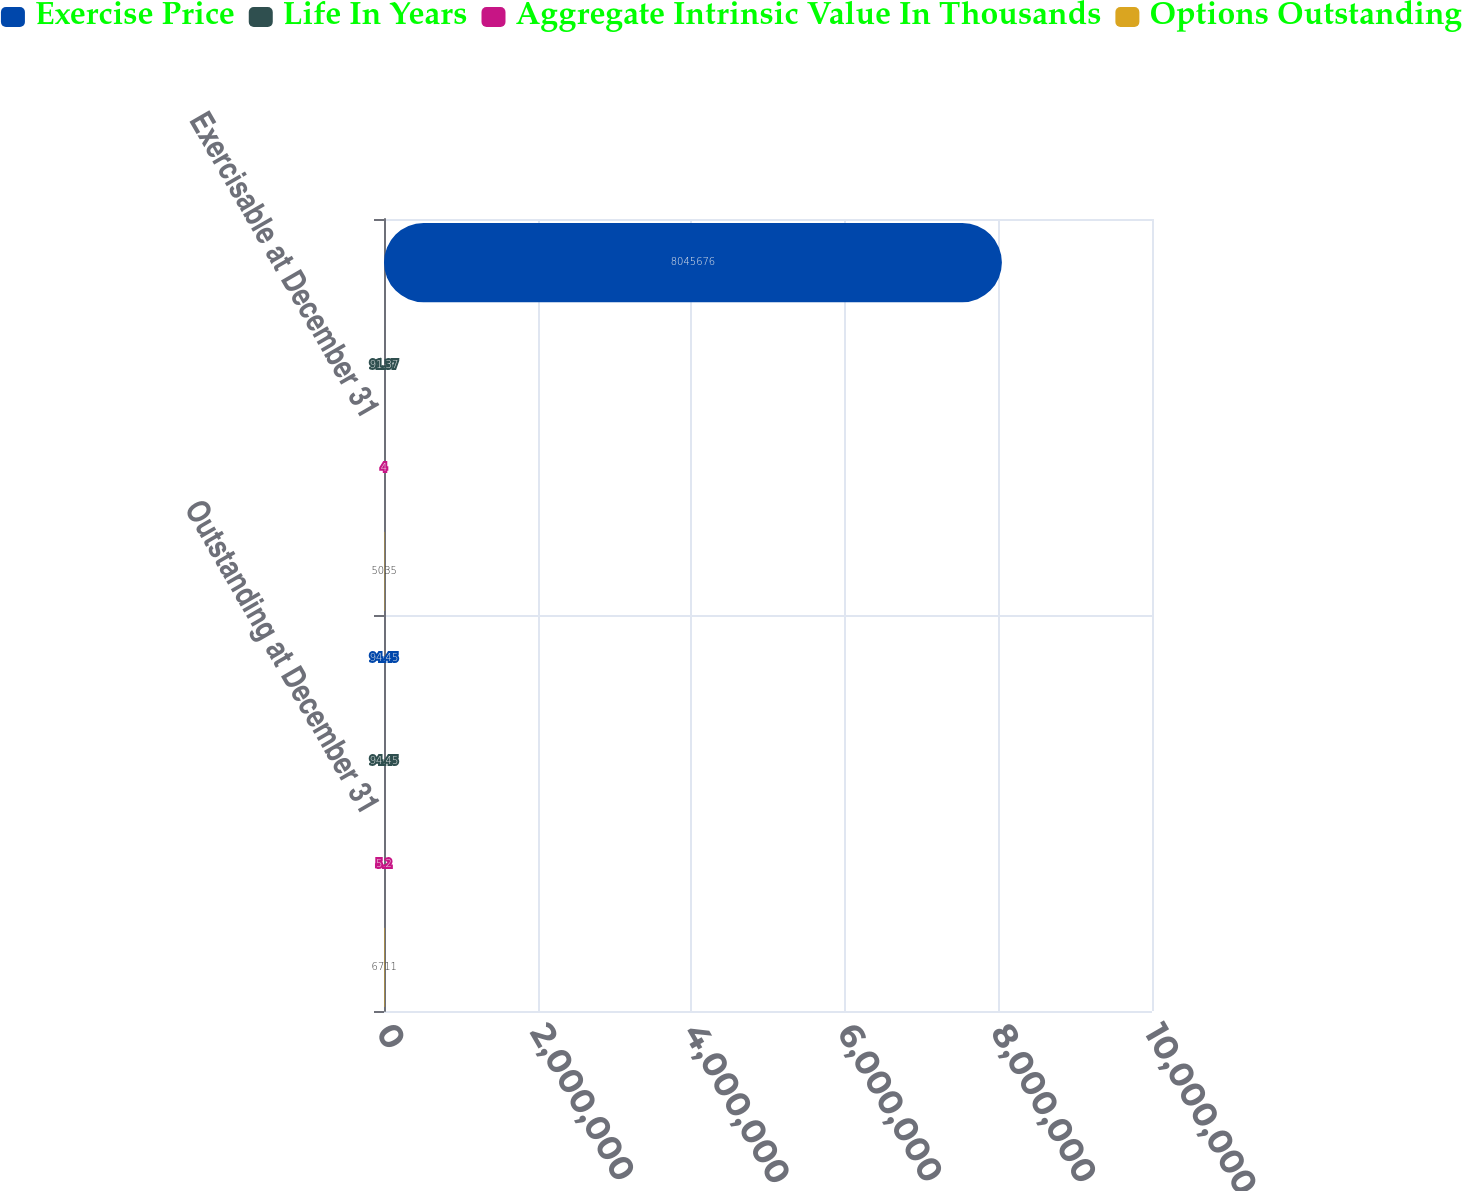Convert chart to OTSL. <chart><loc_0><loc_0><loc_500><loc_500><stacked_bar_chart><ecel><fcel>Outstanding at December 31<fcel>Exercisable at December 31<nl><fcel>Exercise Price<fcel>94.45<fcel>8.04568e+06<nl><fcel>Life In Years<fcel>94.45<fcel>91.37<nl><fcel>Aggregate Intrinsic Value In Thousands<fcel>5.2<fcel>4<nl><fcel>Options Outstanding<fcel>6711<fcel>5035<nl></chart> 